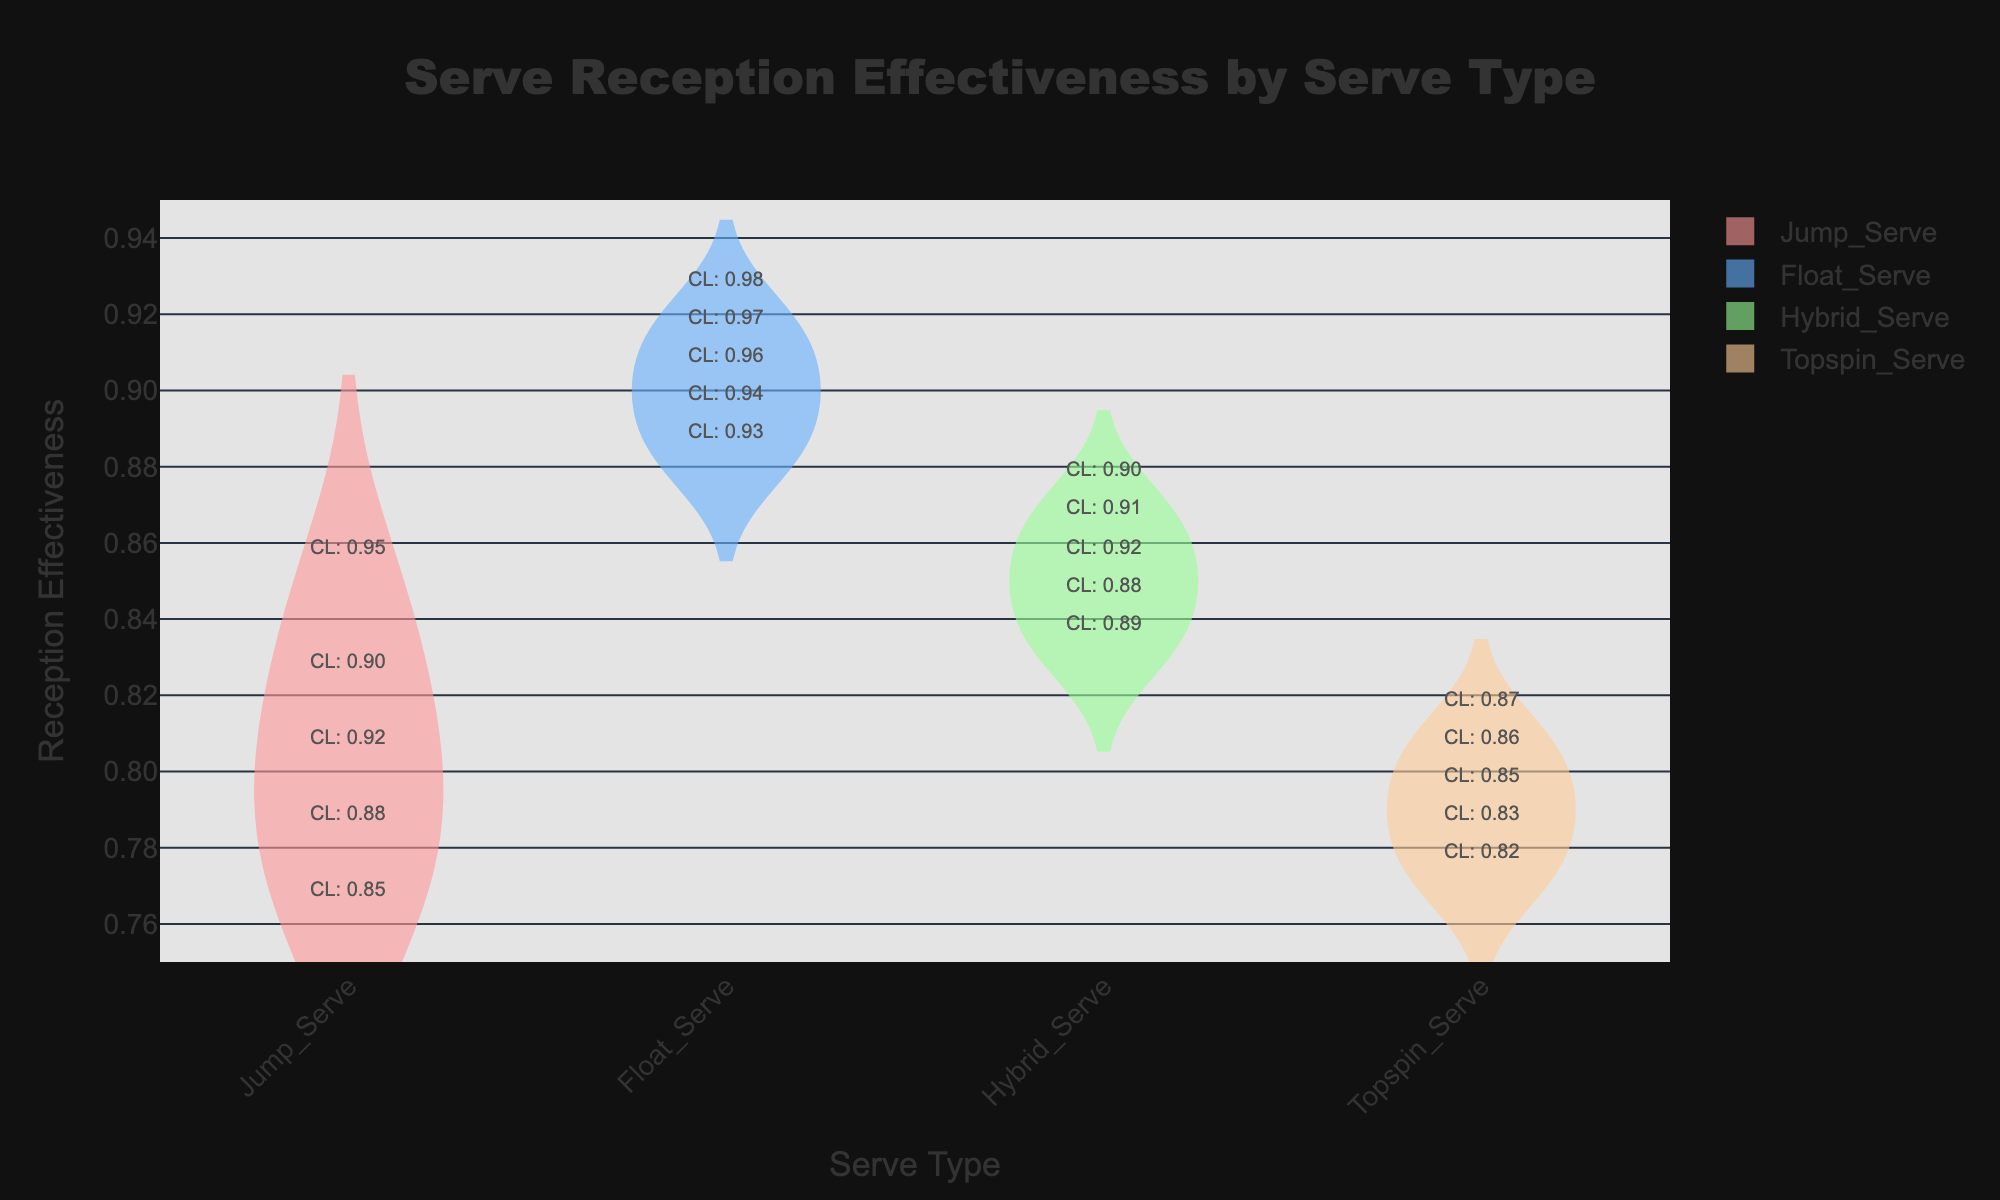What is the title of the figure? The title of a figure is usually displayed at the top, providing a summary of what the figure represents. In this case, it clearly states "Serve Reception Effectiveness by Serve Type".
Answer: "Serve Reception Effectiveness by Serve Type" Which serve type has the highest median reception effectiveness? The box plot overlay within each violin chart shows the median as a line in the center of the box. Comparing the medians visually, the Float Serve has the highest median.
Answer: Float Serve How many distinct serve types are displayed in the figure? Each distinct serve type is represented by a separate violin plot. By counting the different plots, we see there are four: Jump Serve, Float Serve, Hybrid Serve, and Topspin Serve.
Answer: Four What is the range of reception effectiveness values for the Topspin Serve? The range is the difference between the highest and lowest values within the violin plot. For Topspin Serve, the lowest value is about 0.77 and the highest is about 0.81.
Answer: 0.77 to 0.81 Which serve type has the largest interquartile range (IQR) for reception effectiveness? The IQR is represented by the height of the box in the box plot overlay. By comparing the boxes, the Jump Serve appears to have the largest IQR.
Answer: Jump Serve Which serve type has the highest confidence level overlay annotations? The confidence level annotations are the text labels attached to each data point. Observing these, the Float Serve has annotations up to 0.98 which is higher than other serve types.
Answer: Float Serve What is the mean reception effectiveness of the Hybrid Serve? The mean is represented by a line in the center of the box plot overlay. The mean line for Hybrid Serve appears around 0.85.
Answer: 0.85 Is the median reception effectiveness of the Jump Serve higher or lower than that of the Hybrid Serve? By comparing the median lines in the box plots of both serve types, we observe that the median for Jump Serve is slightly lower than that of Hybrid Serve.
Answer: Lower How does the spread of reception effectiveness for Float Serve compare to Jump Serve? The spread can be assessed by looking at the width and overall shape of the violin plot as well as the range within the box plot. The Float Serve has a more narrow spread indicating less variability compared to the wider spread of Jump Serve.
Answer: Float Serve has a narrower spread 